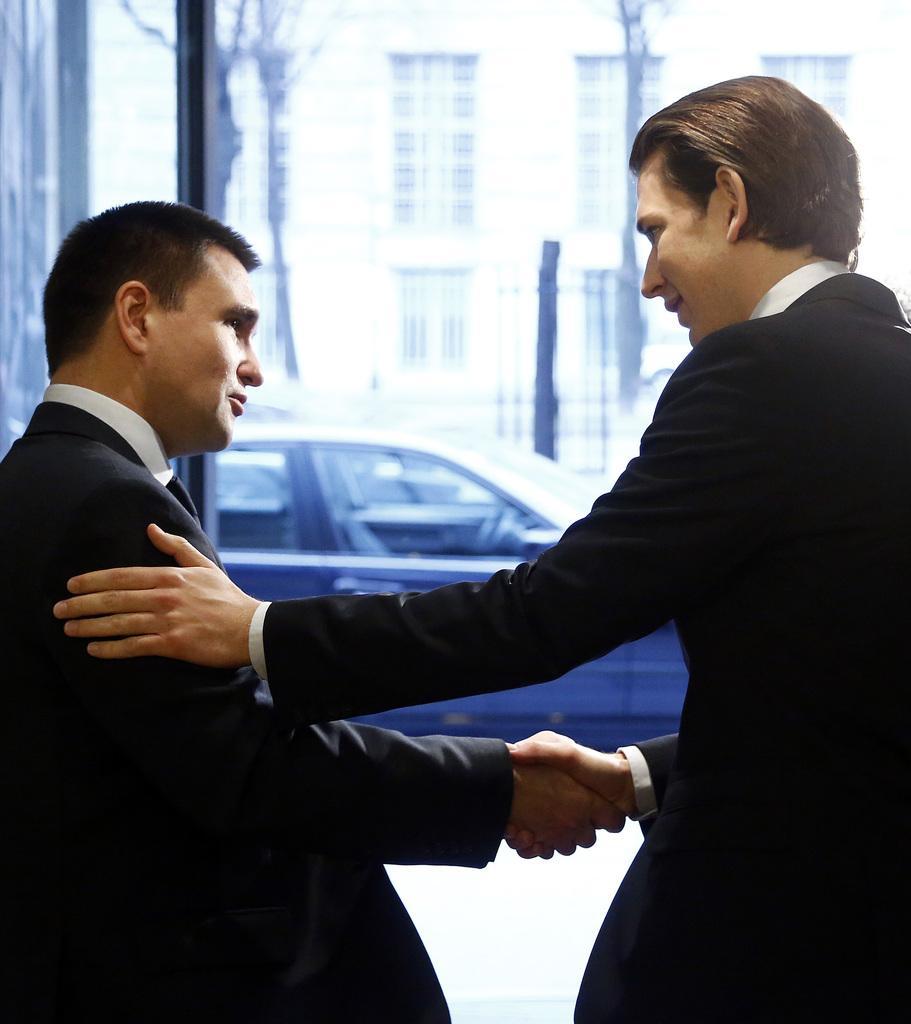Can you describe this image briefly? In this picture, we can see two persons shaking their hands, and in the background we can see some objects like vehicle, building, poles. 